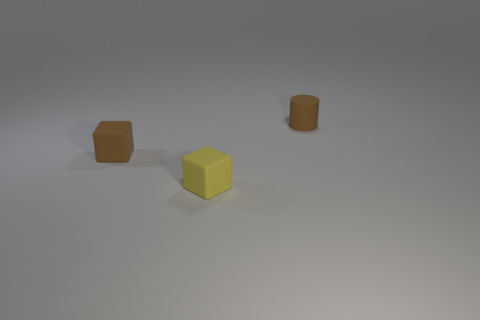What number of other objects are the same size as the yellow rubber object?
Offer a terse response. 2. What number of large objects are yellow matte objects or brown cylinders?
Give a very brief answer. 0. Do the rubber cylinder and the brown rubber thing that is left of the small brown cylinder have the same size?
Offer a very short reply. Yes. How many other objects are the same shape as the yellow object?
Your response must be concise. 1. What shape is the brown object that is the same material as the cylinder?
Give a very brief answer. Cube. Are there any blue metallic spheres?
Ensure brevity in your answer.  No. Is the number of small rubber cubes behind the brown rubber cylinder less than the number of tiny cylinders behind the small brown matte block?
Make the answer very short. Yes. There is a small brown matte thing in front of the tiny brown rubber cylinder; what is its shape?
Make the answer very short. Cube. Do the small brown cylinder and the tiny yellow block have the same material?
Your response must be concise. Yes. Is the number of rubber blocks that are behind the yellow block less than the number of small gray spheres?
Ensure brevity in your answer.  No. 